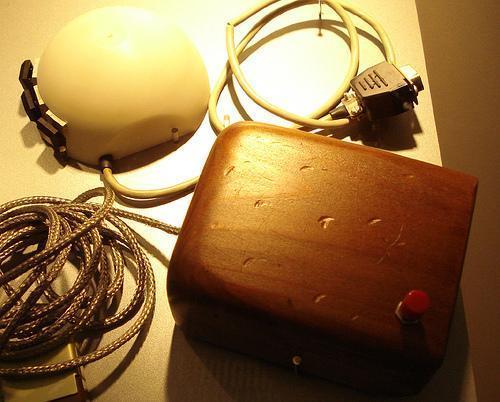How many man sitiing on the elephant?
Give a very brief answer. 0. 